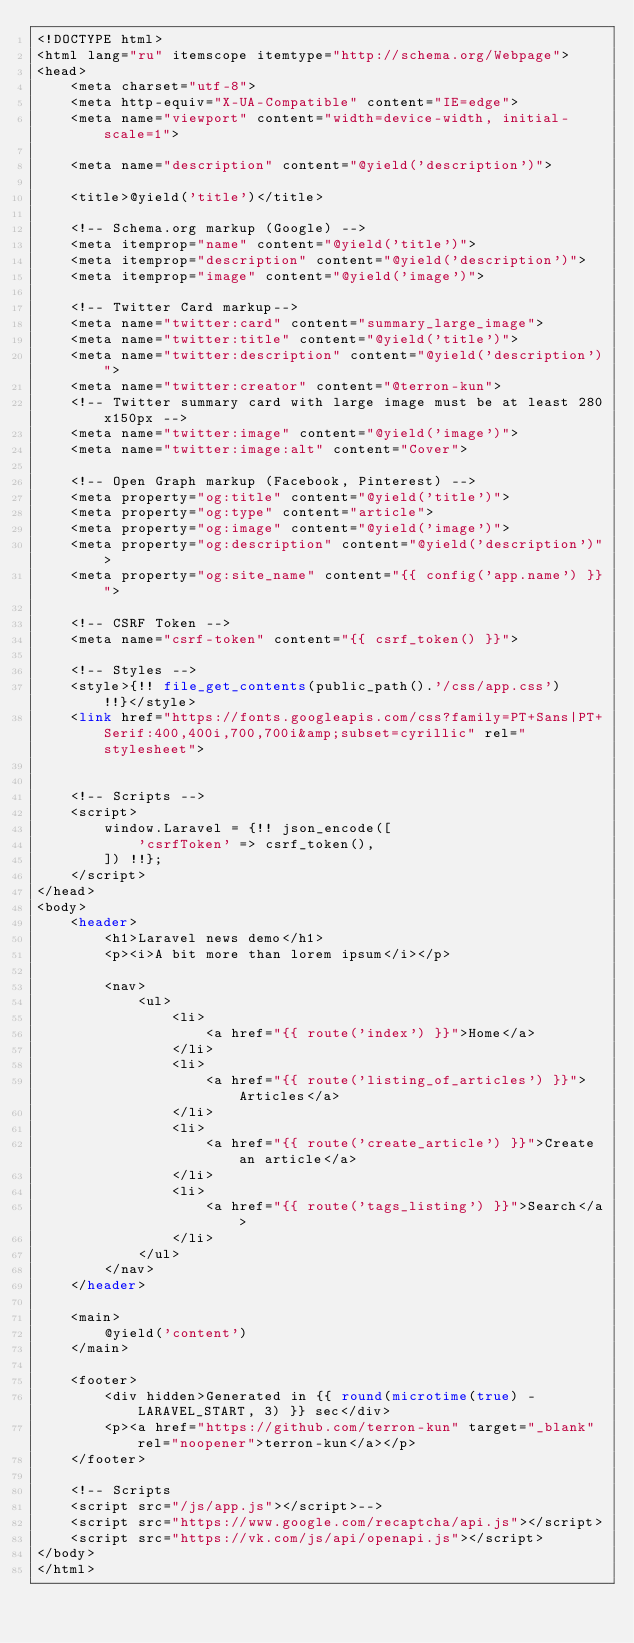<code> <loc_0><loc_0><loc_500><loc_500><_PHP_><!DOCTYPE html>
<html lang="ru" itemscope itemtype="http://schema.org/Webpage">
<head>
    <meta charset="utf-8">
    <meta http-equiv="X-UA-Compatible" content="IE=edge">
    <meta name="viewport" content="width=device-width, initial-scale=1">

    <meta name="description" content="@yield('description')">

    <title>@yield('title')</title>

    <!-- Schema.org markup (Google) -->
    <meta itemprop="name" content="@yield('title')">
    <meta itemprop="description" content="@yield('description')">
    <meta itemprop="image" content="@yield('image')">

    <!-- Twitter Card markup-->
    <meta name="twitter:card" content="summary_large_image">
    <meta name="twitter:title" content="@yield('title')">
    <meta name="twitter:description" content="@yield('description')">
    <meta name="twitter:creator" content="@terron-kun">
    <!-- Twitter summary card with large image must be at least 280x150px -->
    <meta name="twitter:image" content="@yield('image')">
    <meta name="twitter:image:alt" content="Cover">

    <!-- Open Graph markup (Facebook, Pinterest) -->
    <meta property="og:title" content="@yield('title')">
    <meta property="og:type" content="article">
    <meta property="og:image" content="@yield('image')">
    <meta property="og:description" content="@yield('description')">
    <meta property="og:site_name" content="{{ config('app.name') }}">

    <!-- CSRF Token -->
    <meta name="csrf-token" content="{{ csrf_token() }}">

    <!-- Styles -->
    <style>{!! file_get_contents(public_path().'/css/app.css') !!}</style>
    <link href="https://fonts.googleapis.com/css?family=PT+Sans|PT+Serif:400,400i,700,700i&amp;subset=cyrillic" rel="stylesheet">


    <!-- Scripts -->
    <script>
        window.Laravel = {!! json_encode([
            'csrfToken' => csrf_token(),
        ]) !!};
    </script>
</head>
<body>
    <header>
        <h1>Laravel news demo</h1>
        <p><i>A bit more than lorem ipsum</i></p>

        <nav>
            <ul>
                <li>
                    <a href="{{ route('index') }}">Home</a>
                </li>
                <li>
                    <a href="{{ route('listing_of_articles') }}">Articles</a>
                </li>
                <li>
                    <a href="{{ route('create_article') }}">Create an article</a>
                </li>
                <li>
                    <a href="{{ route('tags_listing') }}">Search</a>
                </li>
            </ul>
        </nav>
    </header>

    <main>
        @yield('content')
    </main>

    <footer>
        <div hidden>Generated in {{ round(microtime(true) - LARAVEL_START, 3) }} sec</div>
        <p><a href="https://github.com/terron-kun" target="_blank" rel="noopener">terron-kun</a></p>
    </footer>

    <!-- Scripts
    <script src="/js/app.js"></script>-->
    <script src="https://www.google.com/recaptcha/api.js"></script>
    <script src="https://vk.com/js/api/openapi.js"></script>
</body>
</html></code> 